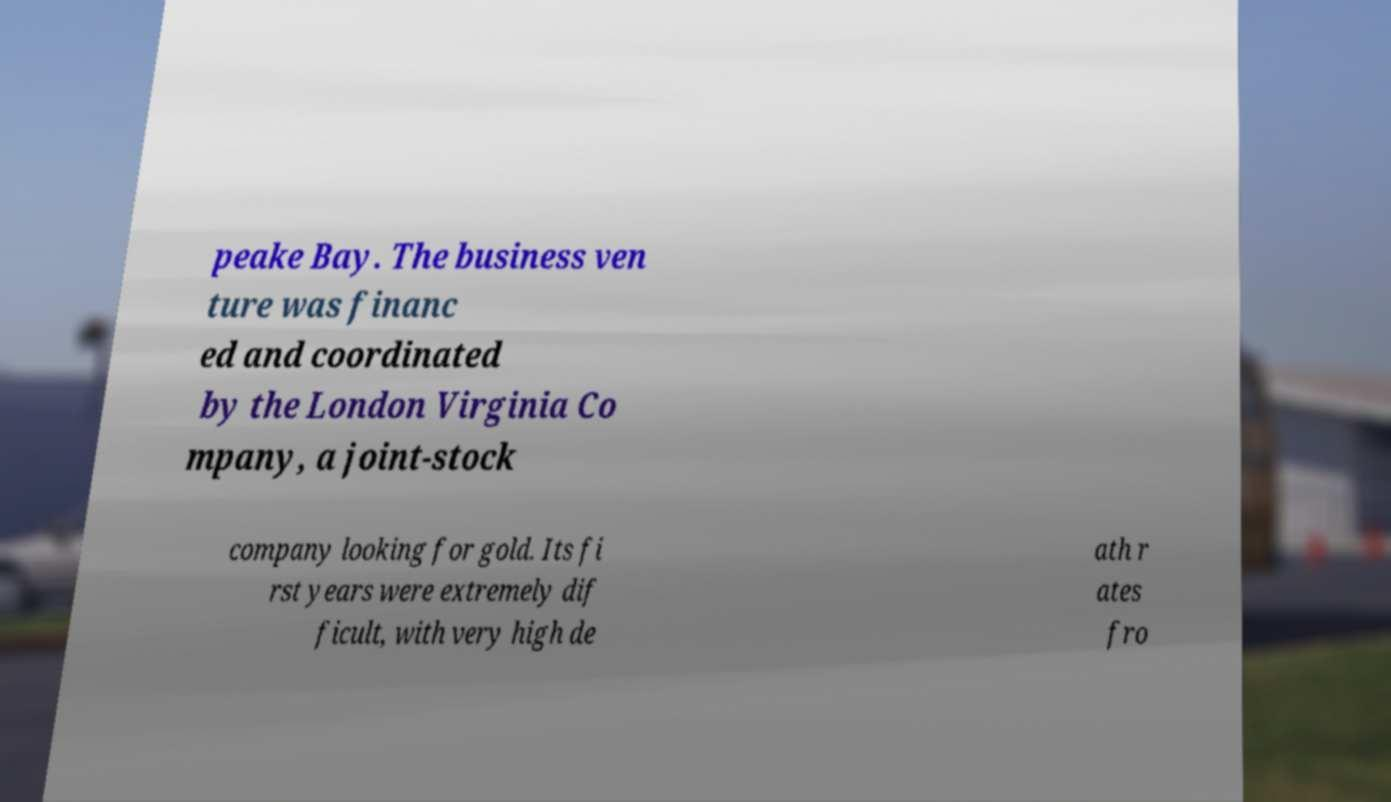Please read and relay the text visible in this image. What does it say? peake Bay. The business ven ture was financ ed and coordinated by the London Virginia Co mpany, a joint-stock company looking for gold. Its fi rst years were extremely dif ficult, with very high de ath r ates fro 